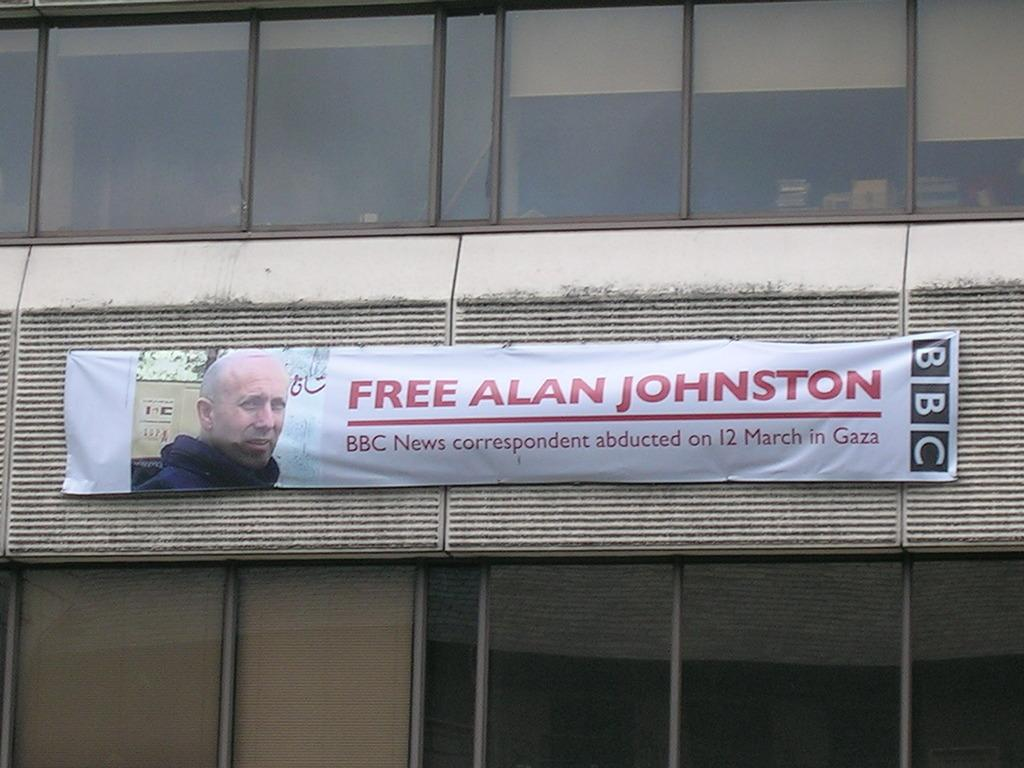What is hanging on the wall in the image? There is a banner on a wall in the image. What is depicted on the banner? The banner contains a picture of a man. Are there any words on the banner? Yes, there is text on the banner. What can be seen through the windows in the image? The presence of windows suggests that there might be a view of the outdoors or other surroundings. How many plants are growing on the banner in the image? There are no plants visible on the banner in the image. What is the limit of the pencil's length in the image? There is no pencil present in the image, so it is not possible to determine its length. 